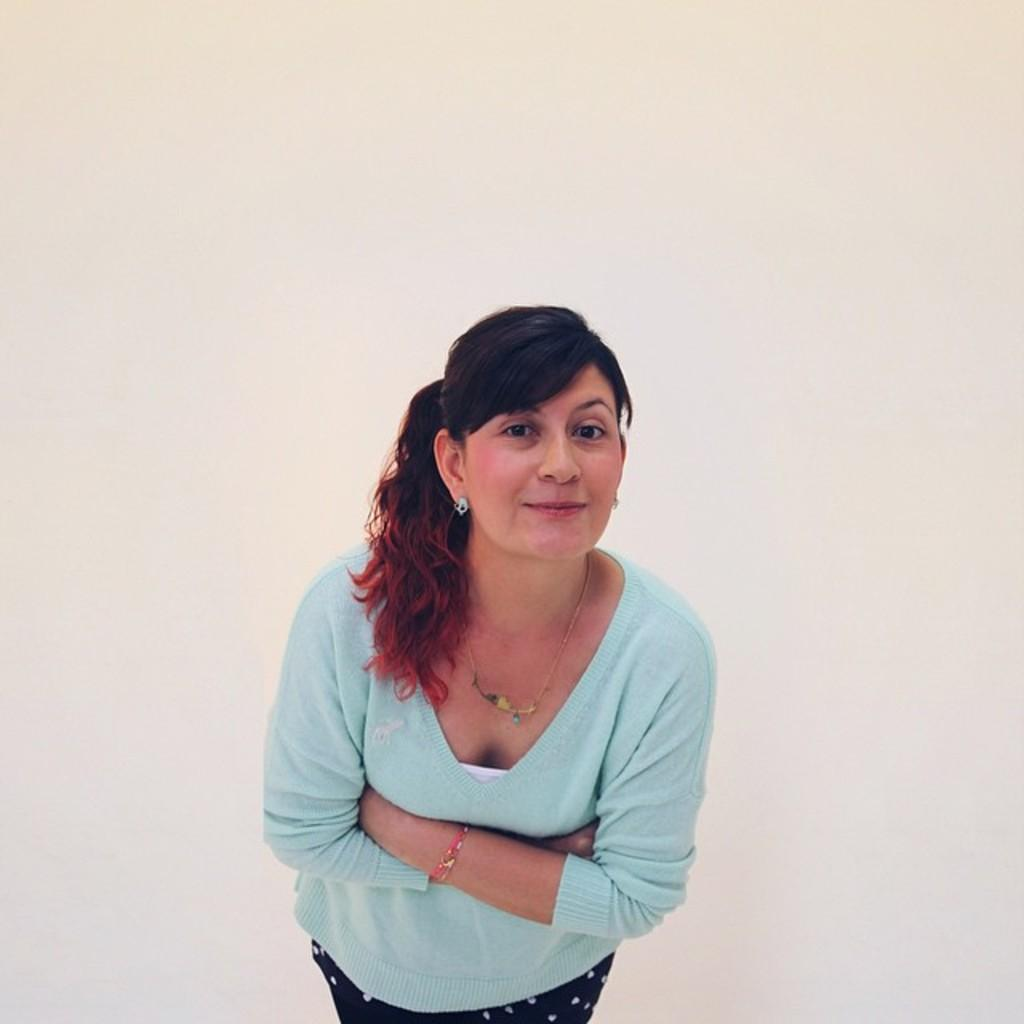Who is present in the image? There is a woman in the image. What expression does the woman have? The woman is smiling. What color is the background of the image? The background of the image is cream-colored. What type of mass is the woman attending in the image? There is no indication of a mass or any religious gathering in the image; it simply features a woman smiling in front of a cream-colored background. Can you see any toads in the image? There are no toads present in the image. 